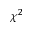<formula> <loc_0><loc_0><loc_500><loc_500>\chi ^ { 2 }</formula> 